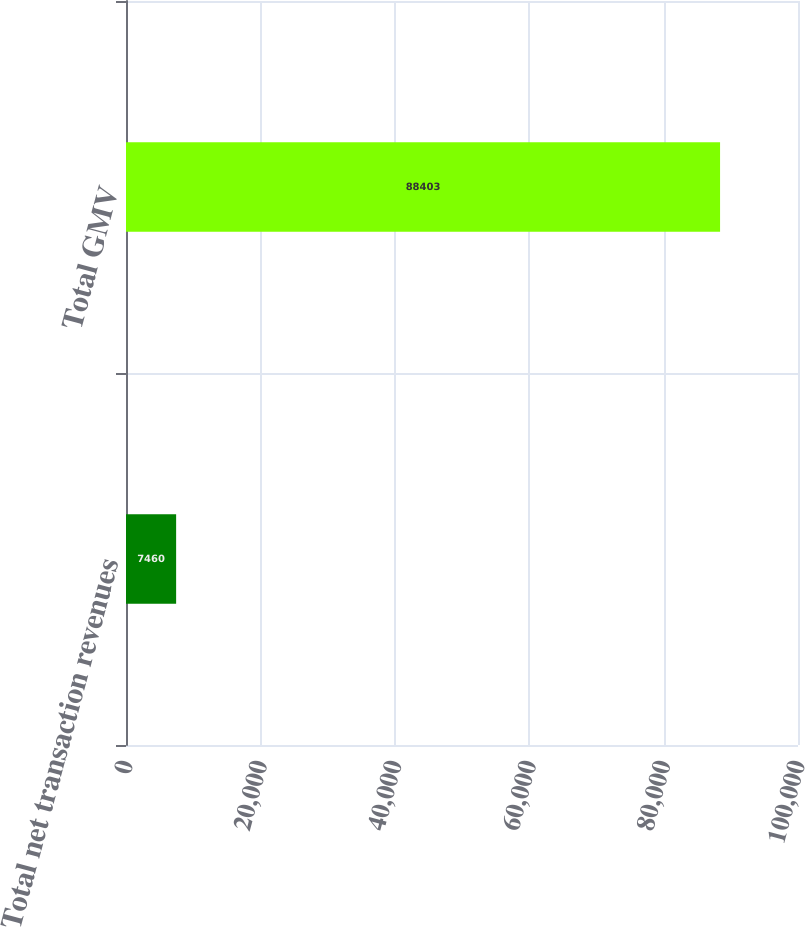Convert chart to OTSL. <chart><loc_0><loc_0><loc_500><loc_500><bar_chart><fcel>Total net transaction revenues<fcel>Total GMV<nl><fcel>7460<fcel>88403<nl></chart> 